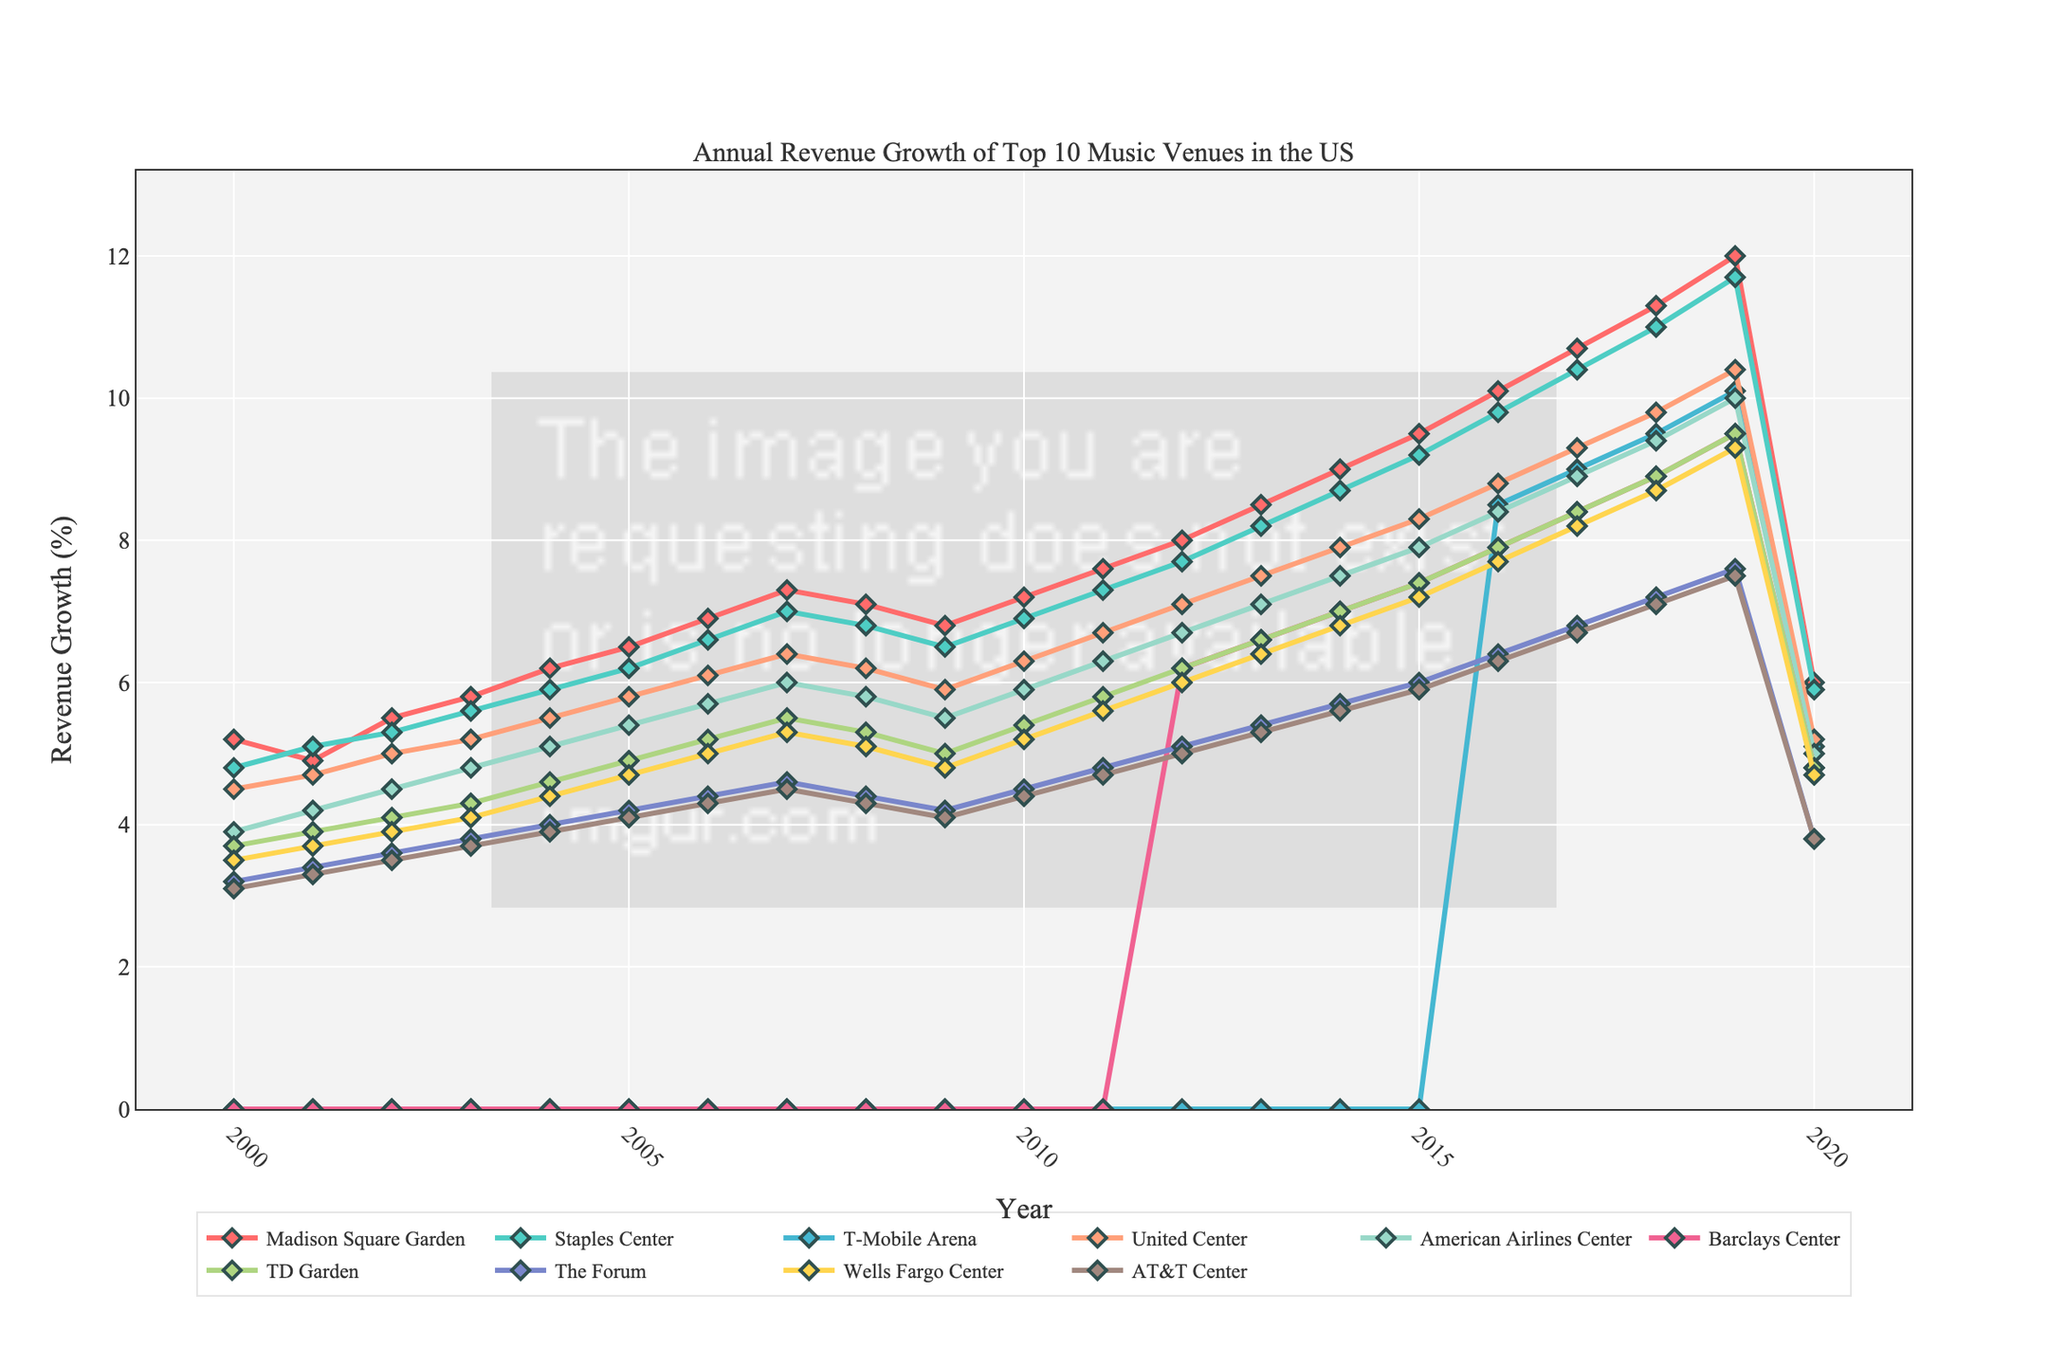What's the average revenue growth of Madison Square Garden over the 20 years? Add the annual revenues of Madison Square Garden from 2000 to 2020 and then divide by 21 (number of years). The calculation is (5.2 + 4.9 + 5.5 + 5.8 + 6.2 + 6.5 + 6.9 + 7.3 + 7.1 + 6.8 + 7.2 + 7.6 + 8.0 + 8.5 + 9.0 + 9.5 + 10.1 + 10.7 + 11.3 + 12.0 + 6.0) / 21 = 7.0238 (approx).
Answer: 7.0 Which music venue had the highest revenue growth in 2019? Look at the revenue growth values for 2019 and identify the highest one among all venues. Madison Square Garden has the highest value with 12.0.
Answer: Madison Square Garden By how much did the revenue growth for T-Mobile Arena change from 2016 to 2020? Subtract the 2020 revenue growth value from the 2016 value for T-Mobile Arena. The calculation is 5.1 - 8.5 = -3.4.
Answer: -3.4 Which venue showed the most consistent revenue growth over the years? To determine consistency, look for a venue whose line appears the smoothest and less erratic. Upon visual inspection, Madison Square Garden shows the smoothest and consistent growth trend.
Answer: Madison Square Garden Compare the revenue growth of American Airlines Center and Barclays Center in 2015. Which one had higher growth? Compare the revenue values for both venues in 2015. American Airlines Center had 7.9, while Barclays Center had 7.4, indicating American Airlines Center had the higher growth.
Answer: American Airlines Center What is the overall trend of the revenue growth for The Forum from 2000 to 2020? Visually inspect the trend of The Forum's revenue growth line over the years. The line shows an overall increasing trend with a significant drop in 2020.
Answer: Increasing trend with a drop in 2020 What is the average revenue growth for all music venues in 2018? Sum the revenue growths of all venues for 2018 and divide by the number of venues. Calculation: (11.3 + 11.0 + 9.5 + 9.8 + 9.4 + 8.9 + 8.9 + 7.2 + 8.7 + 7.1) / 10 = 9.08
Answer: 9.08 Looking at the visual attributes, which music venue has the line colored in green? Identify the colored lines corresponding to each venue. From the colors provided, Staples Center has the green line.
Answer: Staples Center 